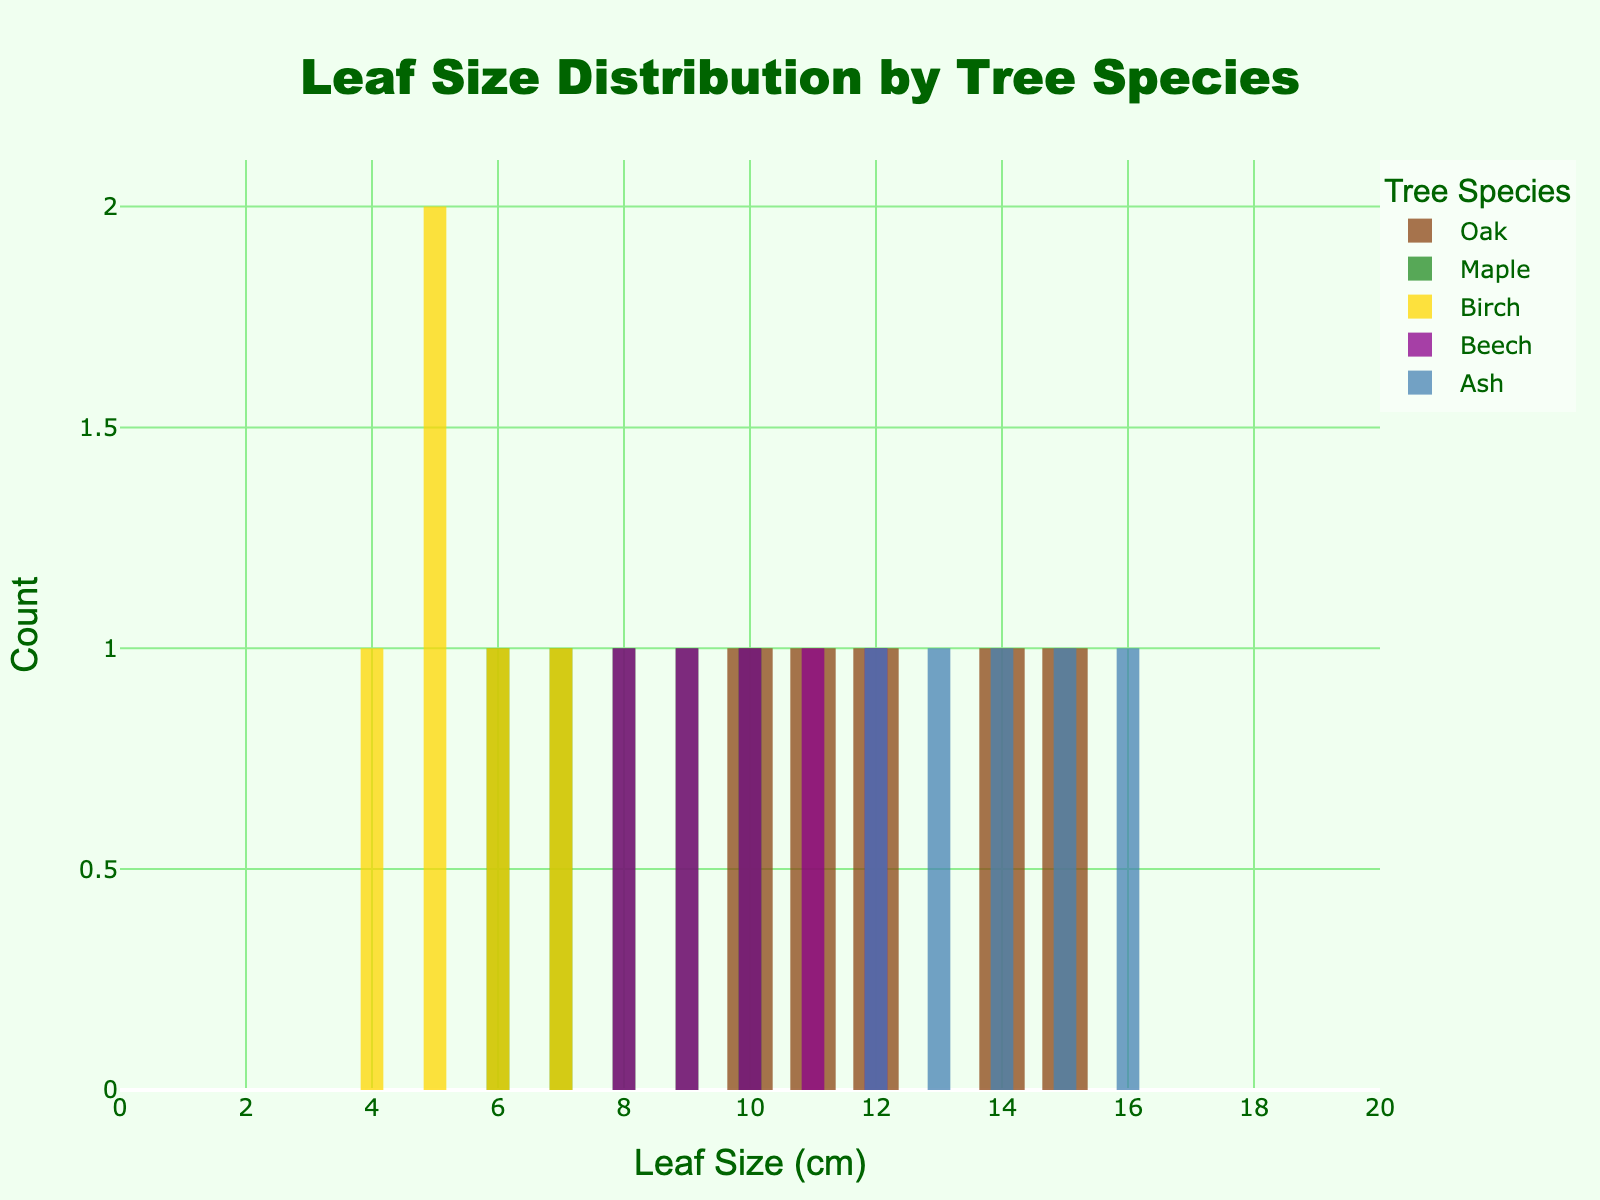How many tree species are shown in the histogram? There are five unique tree species as indicated by the legend on the histogram.
Answer: Five What is the title of the histogram? The title of the histogram is displayed at the top of the figure.
Answer: Leaf Size Distribution by Tree Species Which tree species has the largest range of leaf sizes? Oak and Ash both have the largest leaf size range, from 10 cm to 16 cm. We determine this by comparing the endpoints of each species' leaf size range in the histogram.
Answer: Oak and Ash Which tree species' leaf sizes are mostly in the 4-7 cm range? Birch leaf sizes are mostly within the 4-7 cm range, according to the histogram.
Answer: Birch What is the maximum leaf size for Maple trees shown in the histogram? The maximum leaf size for Maple trees is seen at 10 cm on the histogram.
Answer: 10 cm What is the total number of leaves measured for Ash trees? Counting the number of bars for Ash in the histogram reveals that there are 5 leaves measured, as each bar represents one measurement.
Answer: 5 Which tree species has leaves that span from 8 cm to 12 cm? Beech trees have leaves that span from 8 cm to 12 cm as indicated by the histogram.
Answer: Beech What is the leaf size with the highest frequency for Oak trees? For Oak trees, the most frequent leaf size on the histogram appears to be 15 cm.
Answer: 15 cm Between Maple and Beech, which has a larger spread in leaf sizes and by how much? The spread in leaf sizes for Maple ranges from 6 cm to 10 cm, which is 4 cm. For Beech, it ranges from 8 cm to 12 cm, which is also 4 cm. Therefore, both have the same spread.
Answer: Both have the same spread of 4 cm Which tree species has the smallest variation in their leaf sizes? Birch has the smallest variation in leaf sizes, ranging between 4 cm and 7 cm, a difference of 3 cm. Observe the histogram for the smallest range of leaf sizes.
Answer: Birch 